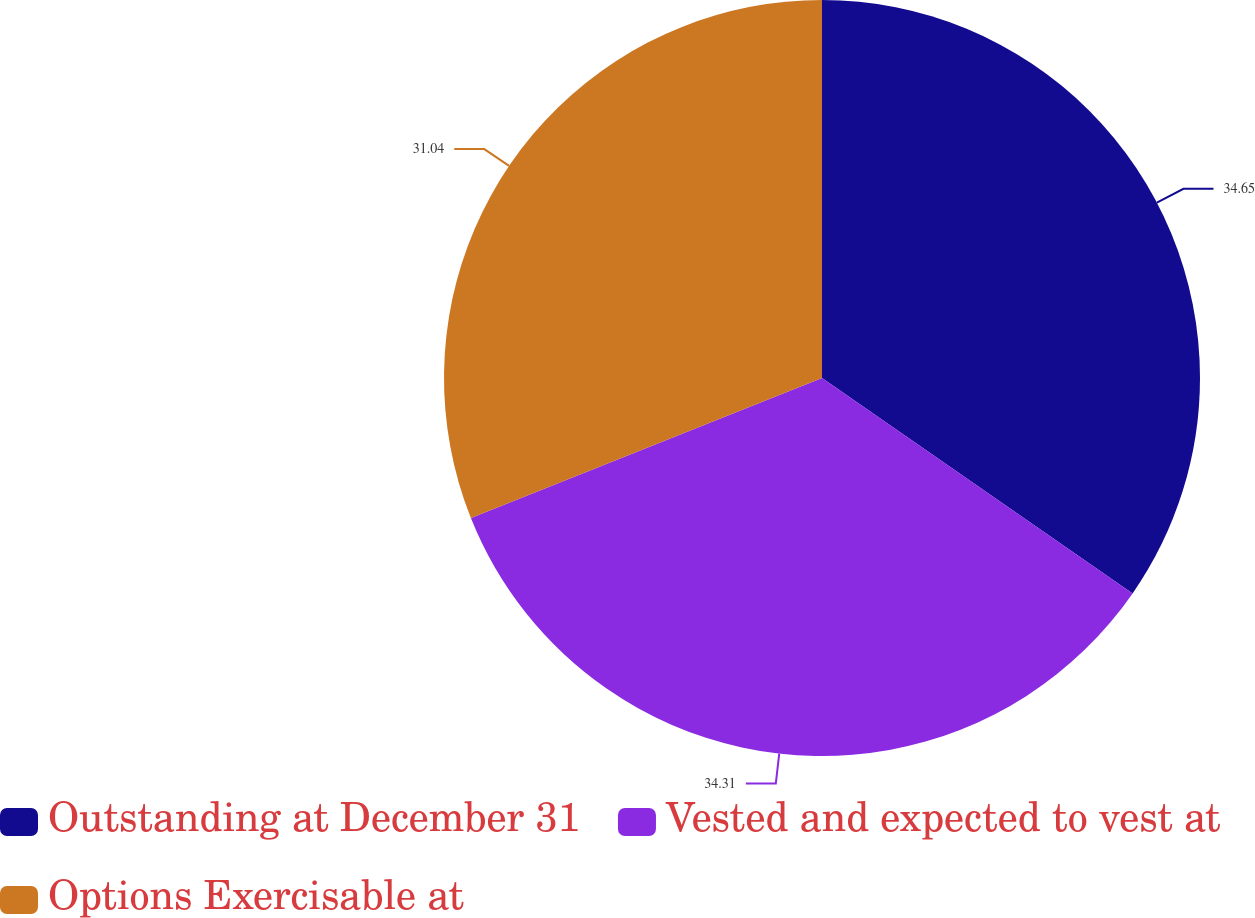<chart> <loc_0><loc_0><loc_500><loc_500><pie_chart><fcel>Outstanding at December 31<fcel>Vested and expected to vest at<fcel>Options Exercisable at<nl><fcel>34.65%<fcel>34.31%<fcel>31.04%<nl></chart> 